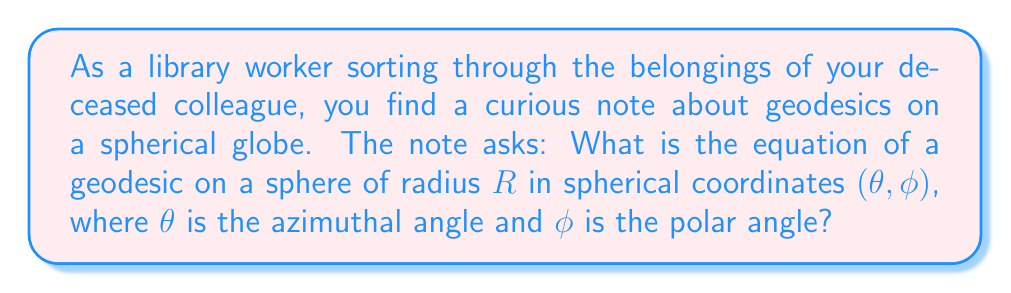Give your solution to this math problem. To determine the equation of a geodesic on a sphere, we'll follow these steps:

1) First, recall that geodesics on a sphere are great circles, which are the intersections of the sphere with planes passing through its center.

2) In spherical coordinates, the parametric equations of a sphere of radius $R$ are:
   $$x = R \sin\phi \cos\theta$$
   $$y = R \sin\phi \sin\theta$$
   $$z = R \cos\phi$$

3) A plane passing through the center of the sphere can be described by the equation:
   $$ax + by + cz = 0$$
   where $a$, $b$, and $c$ are constants.

4) Substituting the parametric equations into this plane equation:
   $$aR \sin\phi \cos\theta + bR \sin\phi \sin\theta + cR \cos\phi = 0$$

5) Dividing by $R$ and rearranging:
   $$a \sin\phi \cos\theta + b \sin\phi \sin\theta = -c \cos\phi$$

6) This can be rewritten as:
   $$\sin\phi (a \cos\theta + b \sin\theta) = -c \cos\phi$$

7) Let $A = \sqrt{a^2 + b^2}$. Then we can write:
   $$a = A \cos\alpha, b = A \sin\alpha$$
   for some angle $\alpha$.

8) Substituting these into our equation:
   $$\sin\phi (A \cos\alpha \cos\theta + A \sin\alpha \sin\theta) = -c \cos\phi$$
   $$A \sin\phi \cos(\theta - \alpha) = -c \cos\phi$$

9) Dividing both sides by $\sqrt{A^2 + c^2}$:
   $$\frac{A}{\sqrt{A^2 + c^2}} \sin\phi \cos(\theta - \alpha) = -\frac{c}{\sqrt{A^2 + c^2}} \cos\phi$$

10) Let $\cos\beta = \frac{c}{\sqrt{A^2 + c^2}}$. Then $\sin\beta = \frac{A}{\sqrt{A^2 + c^2}}$.

11) Our equation becomes:
    $$\sin\beta \sin\phi \cos(\theta - \alpha) = -\cos\beta \cos\phi$$

12) This can be rewritten as:
    $$\cos\beta \cos\phi + \sin\beta \sin\phi \cos(\theta - \alpha) = 0$$

13) Using the cosine addition formula, this is equivalent to:
    $$\cos(\phi - \beta) = 0$$

Therefore, the equation of a geodesic on a sphere in spherical coordinates is:
$$\phi - \beta = \frac{\pi}{2}$$
or
$$\phi = \theta_0 + \frac{\pi}{2}$$
where $\theta_0$ is a constant (equal to $\beta$ in our derivation).
Answer: $\phi = \theta_0 + \frac{\pi}{2}$, where $\theta_0$ is a constant. 